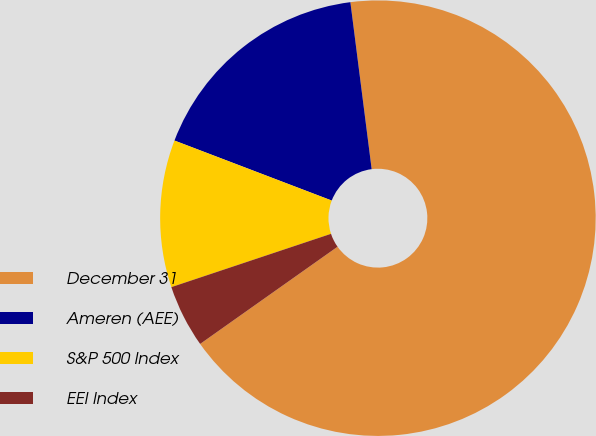Convert chart to OTSL. <chart><loc_0><loc_0><loc_500><loc_500><pie_chart><fcel>December 31<fcel>Ameren (AEE)<fcel>S&P 500 Index<fcel>EEI Index<nl><fcel>67.22%<fcel>17.18%<fcel>10.93%<fcel>4.67%<nl></chart> 